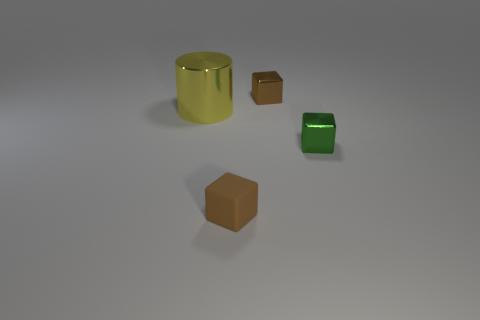Subtract all green cubes. Subtract all cyan cylinders. How many cubes are left? 2 Add 3 large objects. How many objects exist? 7 Subtract all blocks. How many objects are left? 1 Subtract 1 yellow cylinders. How many objects are left? 3 Subtract all large red objects. Subtract all tiny metallic cubes. How many objects are left? 2 Add 3 metal blocks. How many metal blocks are left? 5 Add 4 small blocks. How many small blocks exist? 7 